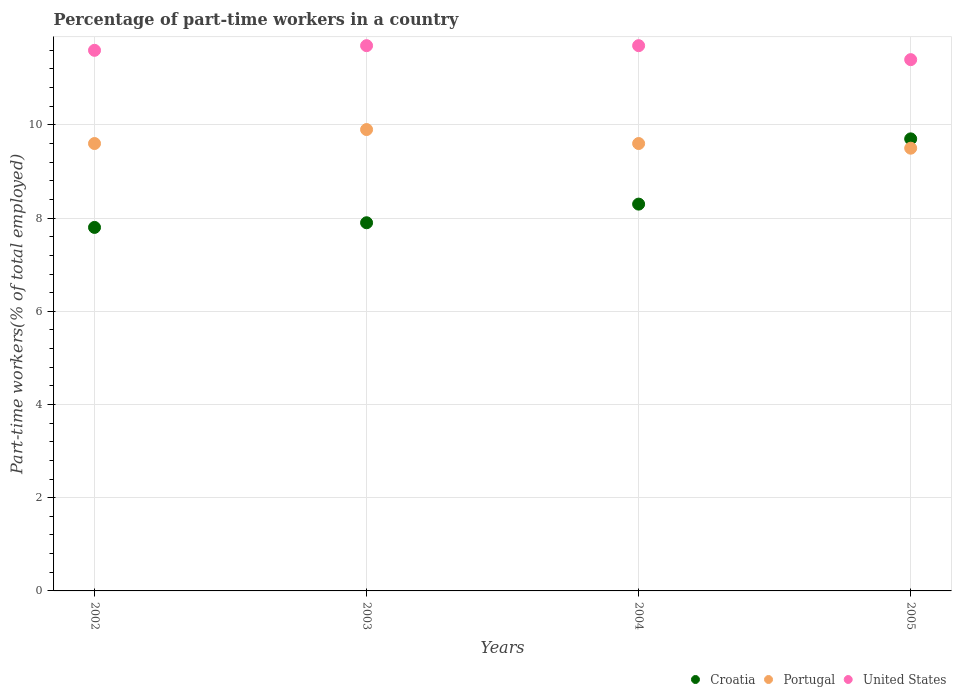How many different coloured dotlines are there?
Give a very brief answer. 3. Is the number of dotlines equal to the number of legend labels?
Your answer should be very brief. Yes. What is the percentage of part-time workers in Portugal in 2003?
Ensure brevity in your answer.  9.9. Across all years, what is the maximum percentage of part-time workers in United States?
Your answer should be very brief. 11.7. Across all years, what is the minimum percentage of part-time workers in United States?
Your answer should be compact. 11.4. What is the total percentage of part-time workers in Croatia in the graph?
Ensure brevity in your answer.  33.7. What is the difference between the percentage of part-time workers in United States in 2003 and that in 2005?
Provide a short and direct response. 0.3. What is the difference between the percentage of part-time workers in Croatia in 2002 and the percentage of part-time workers in United States in 2005?
Ensure brevity in your answer.  -3.6. What is the average percentage of part-time workers in Croatia per year?
Offer a terse response. 8.43. In the year 2004, what is the difference between the percentage of part-time workers in Croatia and percentage of part-time workers in United States?
Give a very brief answer. -3.4. What is the ratio of the percentage of part-time workers in United States in 2002 to that in 2003?
Ensure brevity in your answer.  0.99. Is the percentage of part-time workers in United States in 2003 less than that in 2005?
Provide a short and direct response. No. What is the difference between the highest and the lowest percentage of part-time workers in Croatia?
Your answer should be very brief. 1.9. Is the sum of the percentage of part-time workers in United States in 2002 and 2004 greater than the maximum percentage of part-time workers in Portugal across all years?
Your answer should be very brief. Yes. Is it the case that in every year, the sum of the percentage of part-time workers in Croatia and percentage of part-time workers in Portugal  is greater than the percentage of part-time workers in United States?
Provide a succinct answer. Yes. Is the percentage of part-time workers in Portugal strictly greater than the percentage of part-time workers in United States over the years?
Your answer should be very brief. No. How many dotlines are there?
Your answer should be compact. 3. How many years are there in the graph?
Make the answer very short. 4. What is the difference between two consecutive major ticks on the Y-axis?
Give a very brief answer. 2. Are the values on the major ticks of Y-axis written in scientific E-notation?
Offer a very short reply. No. Does the graph contain grids?
Give a very brief answer. Yes. Where does the legend appear in the graph?
Make the answer very short. Bottom right. How many legend labels are there?
Offer a very short reply. 3. How are the legend labels stacked?
Give a very brief answer. Horizontal. What is the title of the graph?
Provide a short and direct response. Percentage of part-time workers in a country. Does "Cote d'Ivoire" appear as one of the legend labels in the graph?
Give a very brief answer. No. What is the label or title of the Y-axis?
Offer a very short reply. Part-time workers(% of total employed). What is the Part-time workers(% of total employed) in Croatia in 2002?
Make the answer very short. 7.8. What is the Part-time workers(% of total employed) of Portugal in 2002?
Keep it short and to the point. 9.6. What is the Part-time workers(% of total employed) in United States in 2002?
Your response must be concise. 11.6. What is the Part-time workers(% of total employed) in Croatia in 2003?
Provide a short and direct response. 7.9. What is the Part-time workers(% of total employed) in Portugal in 2003?
Provide a succinct answer. 9.9. What is the Part-time workers(% of total employed) in United States in 2003?
Ensure brevity in your answer.  11.7. What is the Part-time workers(% of total employed) of Croatia in 2004?
Offer a terse response. 8.3. What is the Part-time workers(% of total employed) of Portugal in 2004?
Provide a succinct answer. 9.6. What is the Part-time workers(% of total employed) of United States in 2004?
Provide a short and direct response. 11.7. What is the Part-time workers(% of total employed) in Croatia in 2005?
Offer a terse response. 9.7. What is the Part-time workers(% of total employed) of United States in 2005?
Offer a terse response. 11.4. Across all years, what is the maximum Part-time workers(% of total employed) in Croatia?
Ensure brevity in your answer.  9.7. Across all years, what is the maximum Part-time workers(% of total employed) in Portugal?
Your response must be concise. 9.9. Across all years, what is the maximum Part-time workers(% of total employed) of United States?
Offer a terse response. 11.7. Across all years, what is the minimum Part-time workers(% of total employed) in Croatia?
Your answer should be very brief. 7.8. Across all years, what is the minimum Part-time workers(% of total employed) of Portugal?
Ensure brevity in your answer.  9.5. Across all years, what is the minimum Part-time workers(% of total employed) in United States?
Keep it short and to the point. 11.4. What is the total Part-time workers(% of total employed) in Croatia in the graph?
Your answer should be very brief. 33.7. What is the total Part-time workers(% of total employed) in Portugal in the graph?
Ensure brevity in your answer.  38.6. What is the total Part-time workers(% of total employed) in United States in the graph?
Ensure brevity in your answer.  46.4. What is the difference between the Part-time workers(% of total employed) in Croatia in 2002 and that in 2003?
Your answer should be very brief. -0.1. What is the difference between the Part-time workers(% of total employed) of Portugal in 2002 and that in 2003?
Offer a terse response. -0.3. What is the difference between the Part-time workers(% of total employed) in United States in 2002 and that in 2003?
Make the answer very short. -0.1. What is the difference between the Part-time workers(% of total employed) of Portugal in 2002 and that in 2004?
Your response must be concise. 0. What is the difference between the Part-time workers(% of total employed) in United States in 2002 and that in 2004?
Keep it short and to the point. -0.1. What is the difference between the Part-time workers(% of total employed) of Portugal in 2002 and that in 2005?
Provide a short and direct response. 0.1. What is the difference between the Part-time workers(% of total employed) of Croatia in 2003 and that in 2004?
Offer a very short reply. -0.4. What is the difference between the Part-time workers(% of total employed) of Croatia in 2002 and the Part-time workers(% of total employed) of Portugal in 2003?
Provide a short and direct response. -2.1. What is the difference between the Part-time workers(% of total employed) in Portugal in 2002 and the Part-time workers(% of total employed) in United States in 2003?
Your response must be concise. -2.1. What is the difference between the Part-time workers(% of total employed) in Croatia in 2002 and the Part-time workers(% of total employed) in Portugal in 2005?
Keep it short and to the point. -1.7. What is the difference between the Part-time workers(% of total employed) in Croatia in 2002 and the Part-time workers(% of total employed) in United States in 2005?
Offer a very short reply. -3.6. What is the difference between the Part-time workers(% of total employed) in Portugal in 2002 and the Part-time workers(% of total employed) in United States in 2005?
Make the answer very short. -1.8. What is the difference between the Part-time workers(% of total employed) in Croatia in 2003 and the Part-time workers(% of total employed) in Portugal in 2004?
Ensure brevity in your answer.  -1.7. What is the difference between the Part-time workers(% of total employed) of Portugal in 2003 and the Part-time workers(% of total employed) of United States in 2004?
Provide a succinct answer. -1.8. What is the difference between the Part-time workers(% of total employed) in Croatia in 2003 and the Part-time workers(% of total employed) in Portugal in 2005?
Give a very brief answer. -1.6. What is the difference between the Part-time workers(% of total employed) in Croatia in 2003 and the Part-time workers(% of total employed) in United States in 2005?
Your response must be concise. -3.5. What is the difference between the Part-time workers(% of total employed) in Portugal in 2003 and the Part-time workers(% of total employed) in United States in 2005?
Keep it short and to the point. -1.5. What is the difference between the Part-time workers(% of total employed) in Portugal in 2004 and the Part-time workers(% of total employed) in United States in 2005?
Provide a short and direct response. -1.8. What is the average Part-time workers(% of total employed) of Croatia per year?
Offer a terse response. 8.43. What is the average Part-time workers(% of total employed) in Portugal per year?
Ensure brevity in your answer.  9.65. In the year 2002, what is the difference between the Part-time workers(% of total employed) of Croatia and Part-time workers(% of total employed) of Portugal?
Make the answer very short. -1.8. In the year 2003, what is the difference between the Part-time workers(% of total employed) in Portugal and Part-time workers(% of total employed) in United States?
Your answer should be compact. -1.8. In the year 2004, what is the difference between the Part-time workers(% of total employed) in Croatia and Part-time workers(% of total employed) in United States?
Your answer should be very brief. -3.4. In the year 2005, what is the difference between the Part-time workers(% of total employed) of Croatia and Part-time workers(% of total employed) of Portugal?
Your answer should be very brief. 0.2. In the year 2005, what is the difference between the Part-time workers(% of total employed) in Croatia and Part-time workers(% of total employed) in United States?
Your answer should be very brief. -1.7. What is the ratio of the Part-time workers(% of total employed) in Croatia in 2002 to that in 2003?
Provide a short and direct response. 0.99. What is the ratio of the Part-time workers(% of total employed) of Portugal in 2002 to that in 2003?
Your answer should be compact. 0.97. What is the ratio of the Part-time workers(% of total employed) in Croatia in 2002 to that in 2004?
Provide a succinct answer. 0.94. What is the ratio of the Part-time workers(% of total employed) of Portugal in 2002 to that in 2004?
Your answer should be compact. 1. What is the ratio of the Part-time workers(% of total employed) in Croatia in 2002 to that in 2005?
Offer a terse response. 0.8. What is the ratio of the Part-time workers(% of total employed) of Portugal in 2002 to that in 2005?
Give a very brief answer. 1.01. What is the ratio of the Part-time workers(% of total employed) in United States in 2002 to that in 2005?
Offer a terse response. 1.02. What is the ratio of the Part-time workers(% of total employed) of Croatia in 2003 to that in 2004?
Offer a very short reply. 0.95. What is the ratio of the Part-time workers(% of total employed) in Portugal in 2003 to that in 2004?
Keep it short and to the point. 1.03. What is the ratio of the Part-time workers(% of total employed) of United States in 2003 to that in 2004?
Keep it short and to the point. 1. What is the ratio of the Part-time workers(% of total employed) in Croatia in 2003 to that in 2005?
Ensure brevity in your answer.  0.81. What is the ratio of the Part-time workers(% of total employed) of Portugal in 2003 to that in 2005?
Offer a very short reply. 1.04. What is the ratio of the Part-time workers(% of total employed) in United States in 2003 to that in 2005?
Give a very brief answer. 1.03. What is the ratio of the Part-time workers(% of total employed) of Croatia in 2004 to that in 2005?
Keep it short and to the point. 0.86. What is the ratio of the Part-time workers(% of total employed) of Portugal in 2004 to that in 2005?
Your answer should be very brief. 1.01. What is the ratio of the Part-time workers(% of total employed) of United States in 2004 to that in 2005?
Offer a terse response. 1.03. What is the difference between the highest and the second highest Part-time workers(% of total employed) of Portugal?
Provide a succinct answer. 0.3. What is the difference between the highest and the lowest Part-time workers(% of total employed) of Croatia?
Provide a short and direct response. 1.9. 